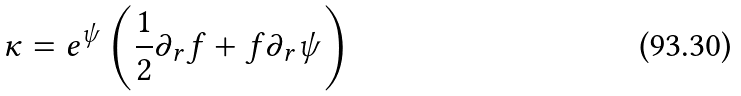<formula> <loc_0><loc_0><loc_500><loc_500>\kappa = e ^ { \psi } \left ( \frac { 1 } { 2 } \partial _ { r } f + f \partial _ { r } \psi \right )</formula> 